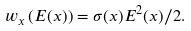<formula> <loc_0><loc_0><loc_500><loc_500>w _ { x } \left ( E ( x ) \right ) = \sigma ( x ) E ^ { 2 } ( x ) / 2 .</formula> 